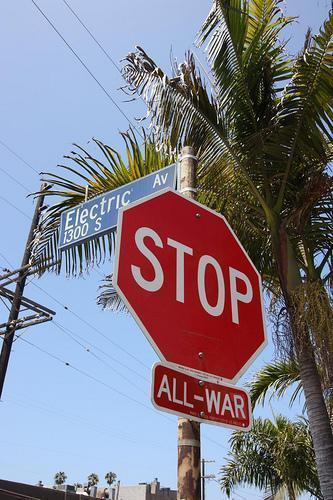How many blue signs are there?
Give a very brief answer. 1. How many red signs are there?
Give a very brief answer. 2. How many road signs are red?
Give a very brief answer. 2. How many road signs are Blue?
Give a very brief answer. 1. How many sides does the STOP sign have?
Give a very brief answer. 8. How many signs are there?
Give a very brief answer. 3. How many stop signs can be seen?
Give a very brief answer. 1. How many adult birds are pictured?
Give a very brief answer. 0. 